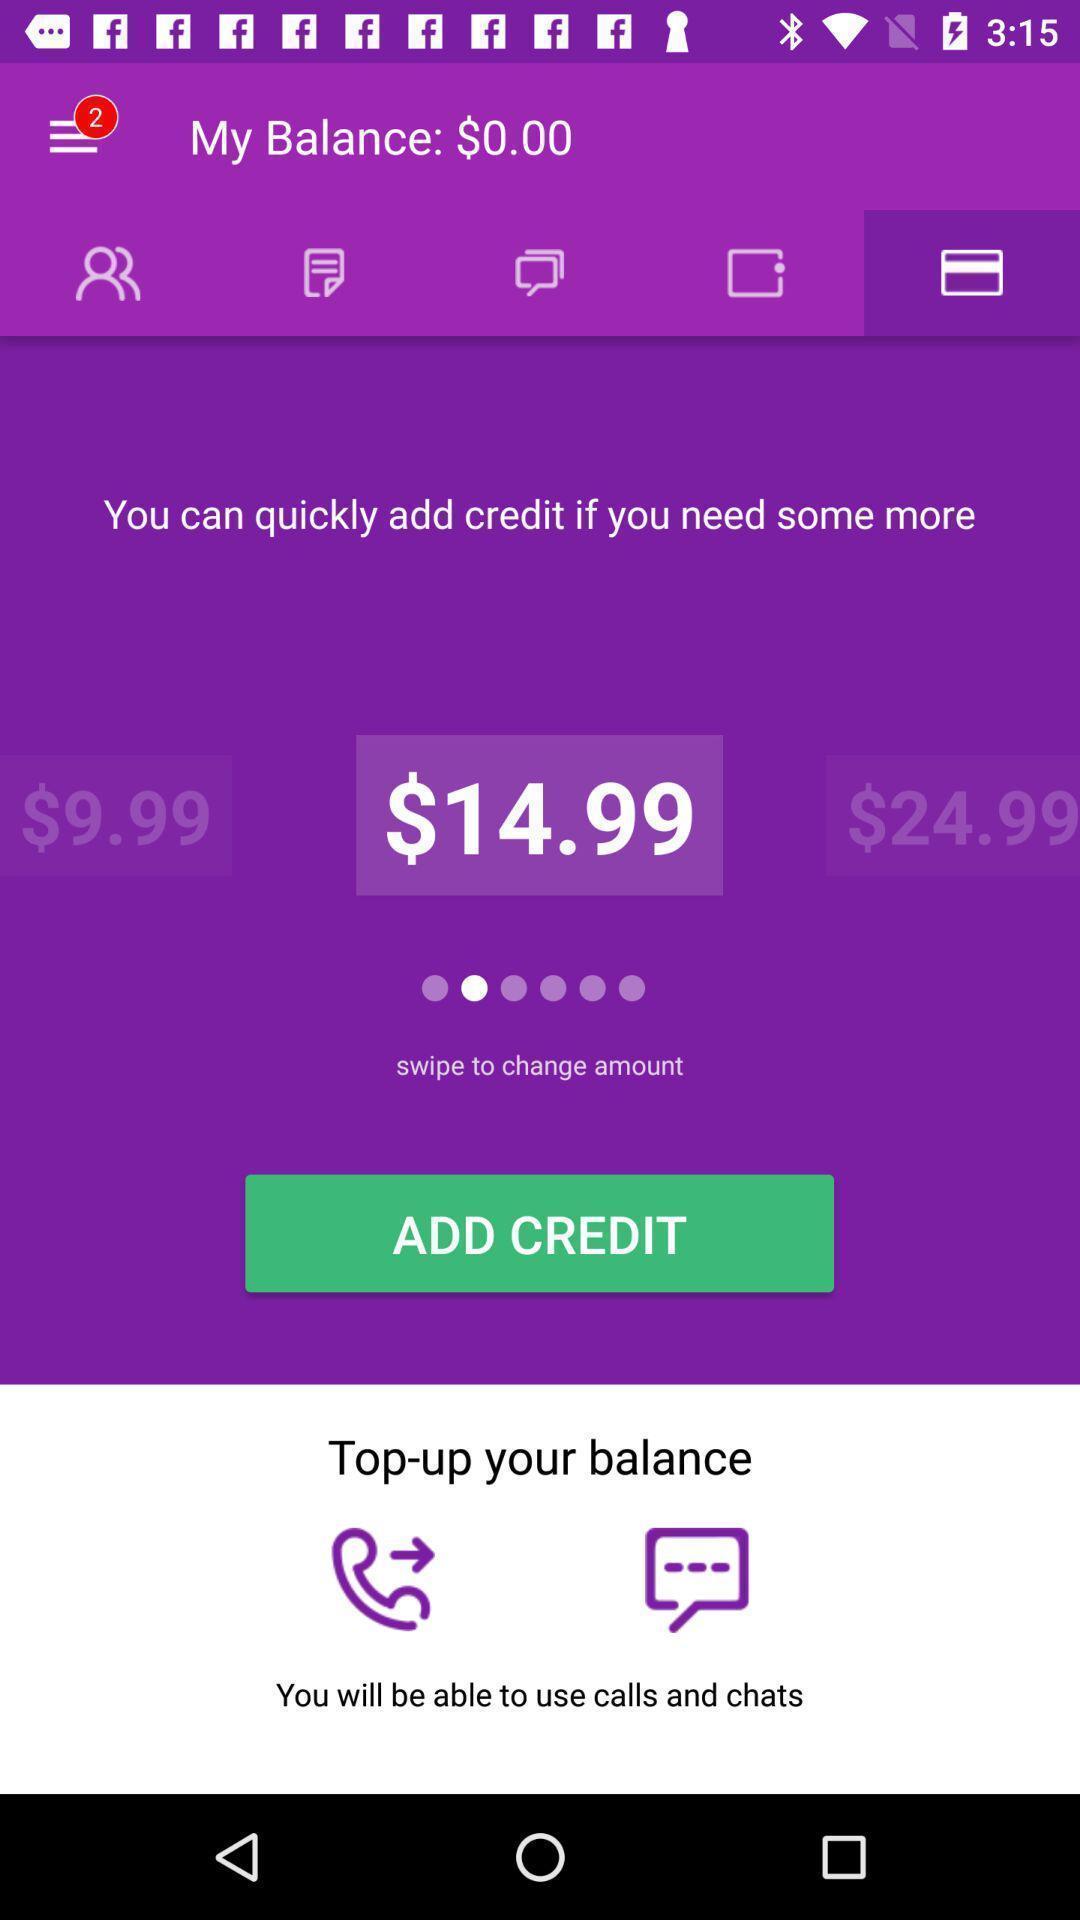Please provide a description for this image. Screen shows credit details. 